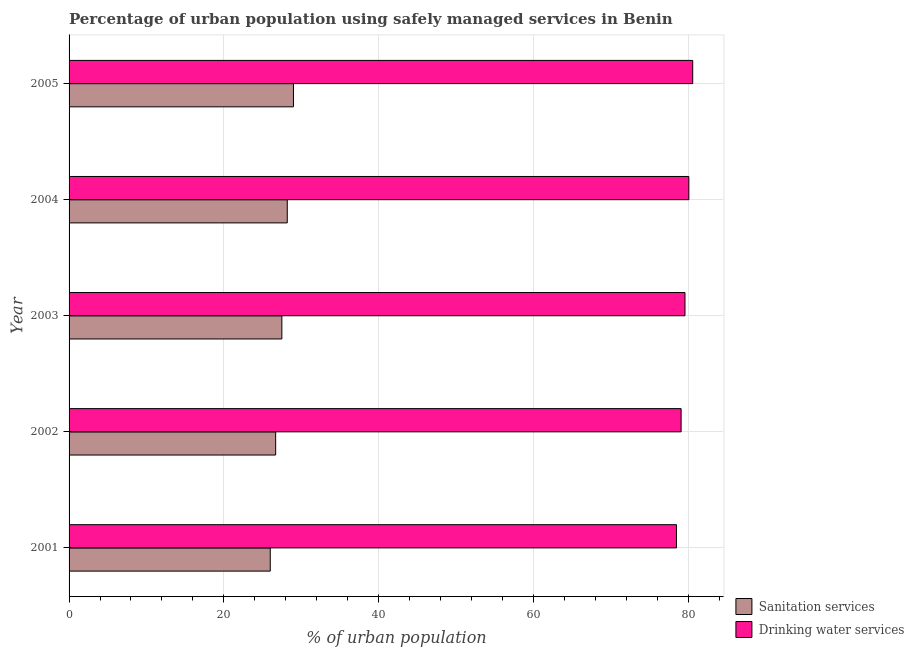How many different coloured bars are there?
Offer a very short reply. 2. How many groups of bars are there?
Offer a very short reply. 5. Are the number of bars on each tick of the Y-axis equal?
Your response must be concise. Yes. How many bars are there on the 3rd tick from the top?
Make the answer very short. 2. What is the label of the 5th group of bars from the top?
Offer a very short reply. 2001. In how many cases, is the number of bars for a given year not equal to the number of legend labels?
Offer a terse response. 0. What is the percentage of urban population who used sanitation services in 2002?
Provide a succinct answer. 26.7. Across all years, what is the maximum percentage of urban population who used drinking water services?
Give a very brief answer. 80.6. In which year was the percentage of urban population who used drinking water services maximum?
Give a very brief answer. 2005. In which year was the percentage of urban population who used drinking water services minimum?
Your answer should be very brief. 2001. What is the total percentage of urban population who used drinking water services in the graph?
Offer a terse response. 397.9. What is the difference between the percentage of urban population who used sanitation services in 2002 and that in 2005?
Keep it short and to the point. -2.3. What is the difference between the percentage of urban population who used drinking water services in 2002 and the percentage of urban population who used sanitation services in 2005?
Ensure brevity in your answer.  50.1. What is the average percentage of urban population who used sanitation services per year?
Your answer should be compact. 27.48. In the year 2004, what is the difference between the percentage of urban population who used drinking water services and percentage of urban population who used sanitation services?
Provide a short and direct response. 51.9. What is the ratio of the percentage of urban population who used sanitation services in 2003 to that in 2005?
Make the answer very short. 0.95. Is the percentage of urban population who used drinking water services in 2001 less than that in 2003?
Your answer should be compact. Yes. Is the difference between the percentage of urban population who used drinking water services in 2001 and 2005 greater than the difference between the percentage of urban population who used sanitation services in 2001 and 2005?
Make the answer very short. Yes. What is the difference between the highest and the lowest percentage of urban population who used drinking water services?
Offer a terse response. 2.1. Is the sum of the percentage of urban population who used sanitation services in 2004 and 2005 greater than the maximum percentage of urban population who used drinking water services across all years?
Keep it short and to the point. No. What does the 1st bar from the top in 2005 represents?
Provide a succinct answer. Drinking water services. What does the 2nd bar from the bottom in 2002 represents?
Make the answer very short. Drinking water services. How many bars are there?
Make the answer very short. 10. Does the graph contain grids?
Offer a terse response. Yes. What is the title of the graph?
Provide a short and direct response. Percentage of urban population using safely managed services in Benin. What is the label or title of the X-axis?
Your answer should be very brief. % of urban population. What is the % of urban population of Drinking water services in 2001?
Your answer should be compact. 78.5. What is the % of urban population of Sanitation services in 2002?
Offer a very short reply. 26.7. What is the % of urban population in Drinking water services in 2002?
Your answer should be very brief. 79.1. What is the % of urban population of Sanitation services in 2003?
Make the answer very short. 27.5. What is the % of urban population of Drinking water services in 2003?
Offer a terse response. 79.6. What is the % of urban population in Sanitation services in 2004?
Your answer should be very brief. 28.2. What is the % of urban population of Drinking water services in 2004?
Your answer should be compact. 80.1. What is the % of urban population of Drinking water services in 2005?
Provide a short and direct response. 80.6. Across all years, what is the maximum % of urban population of Sanitation services?
Give a very brief answer. 29. Across all years, what is the maximum % of urban population of Drinking water services?
Offer a very short reply. 80.6. Across all years, what is the minimum % of urban population of Sanitation services?
Make the answer very short. 26. Across all years, what is the minimum % of urban population in Drinking water services?
Your response must be concise. 78.5. What is the total % of urban population of Sanitation services in the graph?
Your answer should be compact. 137.4. What is the total % of urban population in Drinking water services in the graph?
Your response must be concise. 397.9. What is the difference between the % of urban population of Drinking water services in 2001 and that in 2002?
Give a very brief answer. -0.6. What is the difference between the % of urban population in Drinking water services in 2001 and that in 2003?
Your answer should be very brief. -1.1. What is the difference between the % of urban population in Sanitation services in 2001 and that in 2004?
Ensure brevity in your answer.  -2.2. What is the difference between the % of urban population in Drinking water services in 2001 and that in 2004?
Your answer should be very brief. -1.6. What is the difference between the % of urban population of Sanitation services in 2001 and that in 2005?
Keep it short and to the point. -3. What is the difference between the % of urban population of Drinking water services in 2002 and that in 2003?
Offer a terse response. -0.5. What is the difference between the % of urban population of Sanitation services in 2002 and that in 2005?
Keep it short and to the point. -2.3. What is the difference between the % of urban population of Drinking water services in 2002 and that in 2005?
Provide a short and direct response. -1.5. What is the difference between the % of urban population in Sanitation services in 2003 and that in 2004?
Give a very brief answer. -0.7. What is the difference between the % of urban population of Drinking water services in 2003 and that in 2004?
Offer a terse response. -0.5. What is the difference between the % of urban population in Sanitation services in 2003 and that in 2005?
Provide a succinct answer. -1.5. What is the difference between the % of urban population in Sanitation services in 2004 and that in 2005?
Offer a terse response. -0.8. What is the difference between the % of urban population of Sanitation services in 2001 and the % of urban population of Drinking water services in 2002?
Offer a terse response. -53.1. What is the difference between the % of urban population in Sanitation services in 2001 and the % of urban population in Drinking water services in 2003?
Your answer should be very brief. -53.6. What is the difference between the % of urban population in Sanitation services in 2001 and the % of urban population in Drinking water services in 2004?
Ensure brevity in your answer.  -54.1. What is the difference between the % of urban population in Sanitation services in 2001 and the % of urban population in Drinking water services in 2005?
Ensure brevity in your answer.  -54.6. What is the difference between the % of urban population in Sanitation services in 2002 and the % of urban population in Drinking water services in 2003?
Offer a very short reply. -52.9. What is the difference between the % of urban population in Sanitation services in 2002 and the % of urban population in Drinking water services in 2004?
Ensure brevity in your answer.  -53.4. What is the difference between the % of urban population of Sanitation services in 2002 and the % of urban population of Drinking water services in 2005?
Give a very brief answer. -53.9. What is the difference between the % of urban population in Sanitation services in 2003 and the % of urban population in Drinking water services in 2004?
Your answer should be very brief. -52.6. What is the difference between the % of urban population in Sanitation services in 2003 and the % of urban population in Drinking water services in 2005?
Your answer should be very brief. -53.1. What is the difference between the % of urban population of Sanitation services in 2004 and the % of urban population of Drinking water services in 2005?
Give a very brief answer. -52.4. What is the average % of urban population of Sanitation services per year?
Your answer should be very brief. 27.48. What is the average % of urban population in Drinking water services per year?
Provide a succinct answer. 79.58. In the year 2001, what is the difference between the % of urban population in Sanitation services and % of urban population in Drinking water services?
Provide a short and direct response. -52.5. In the year 2002, what is the difference between the % of urban population in Sanitation services and % of urban population in Drinking water services?
Keep it short and to the point. -52.4. In the year 2003, what is the difference between the % of urban population in Sanitation services and % of urban population in Drinking water services?
Offer a terse response. -52.1. In the year 2004, what is the difference between the % of urban population in Sanitation services and % of urban population in Drinking water services?
Your answer should be compact. -51.9. In the year 2005, what is the difference between the % of urban population in Sanitation services and % of urban population in Drinking water services?
Keep it short and to the point. -51.6. What is the ratio of the % of urban population of Sanitation services in 2001 to that in 2002?
Make the answer very short. 0.97. What is the ratio of the % of urban population of Drinking water services in 2001 to that in 2002?
Provide a succinct answer. 0.99. What is the ratio of the % of urban population in Sanitation services in 2001 to that in 2003?
Offer a terse response. 0.95. What is the ratio of the % of urban population of Drinking water services in 2001 to that in 2003?
Give a very brief answer. 0.99. What is the ratio of the % of urban population in Sanitation services in 2001 to that in 2004?
Give a very brief answer. 0.92. What is the ratio of the % of urban population in Sanitation services in 2001 to that in 2005?
Your response must be concise. 0.9. What is the ratio of the % of urban population in Drinking water services in 2001 to that in 2005?
Keep it short and to the point. 0.97. What is the ratio of the % of urban population of Sanitation services in 2002 to that in 2003?
Your response must be concise. 0.97. What is the ratio of the % of urban population of Drinking water services in 2002 to that in 2003?
Offer a terse response. 0.99. What is the ratio of the % of urban population of Sanitation services in 2002 to that in 2004?
Provide a succinct answer. 0.95. What is the ratio of the % of urban population in Drinking water services in 2002 to that in 2004?
Ensure brevity in your answer.  0.99. What is the ratio of the % of urban population of Sanitation services in 2002 to that in 2005?
Offer a terse response. 0.92. What is the ratio of the % of urban population of Drinking water services in 2002 to that in 2005?
Offer a terse response. 0.98. What is the ratio of the % of urban population of Sanitation services in 2003 to that in 2004?
Your answer should be very brief. 0.98. What is the ratio of the % of urban population of Drinking water services in 2003 to that in 2004?
Your answer should be compact. 0.99. What is the ratio of the % of urban population of Sanitation services in 2003 to that in 2005?
Keep it short and to the point. 0.95. What is the ratio of the % of urban population of Drinking water services in 2003 to that in 2005?
Provide a succinct answer. 0.99. What is the ratio of the % of urban population in Sanitation services in 2004 to that in 2005?
Keep it short and to the point. 0.97. What is the ratio of the % of urban population in Drinking water services in 2004 to that in 2005?
Offer a terse response. 0.99. What is the difference between the highest and the second highest % of urban population in Sanitation services?
Provide a succinct answer. 0.8. What is the difference between the highest and the lowest % of urban population in Sanitation services?
Your response must be concise. 3. What is the difference between the highest and the lowest % of urban population in Drinking water services?
Offer a very short reply. 2.1. 